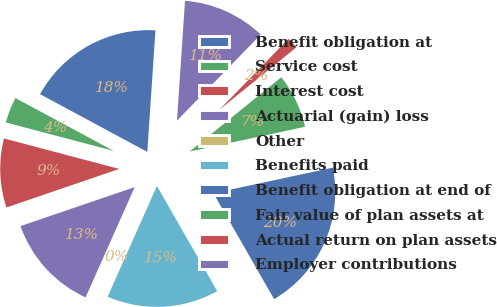Convert chart to OTSL. <chart><loc_0><loc_0><loc_500><loc_500><pie_chart><fcel>Benefit obligation at<fcel>Service cost<fcel>Interest cost<fcel>Actuarial (gain) loss<fcel>Other<fcel>Benefits paid<fcel>Benefit obligation at end of<fcel>Fair value of plan assets at<fcel>Actual return on plan assets<fcel>Employer contributions<nl><fcel>18.21%<fcel>3.74%<fcel>9.35%<fcel>13.09%<fcel>0.0%<fcel>14.95%<fcel>20.08%<fcel>7.48%<fcel>1.87%<fcel>11.22%<nl></chart> 